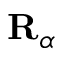Convert formula to latex. <formula><loc_0><loc_0><loc_500><loc_500>R _ { \alpha }</formula> 